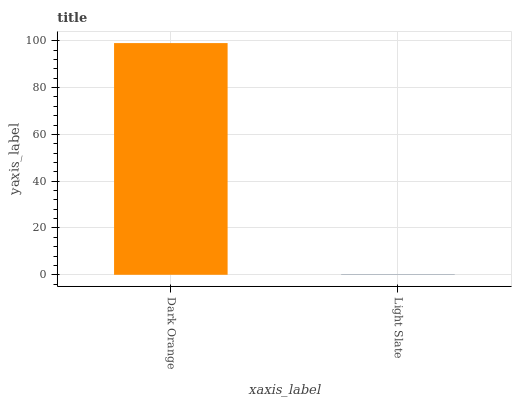Is Light Slate the minimum?
Answer yes or no. Yes. Is Dark Orange the maximum?
Answer yes or no. Yes. Is Light Slate the maximum?
Answer yes or no. No. Is Dark Orange greater than Light Slate?
Answer yes or no. Yes. Is Light Slate less than Dark Orange?
Answer yes or no. Yes. Is Light Slate greater than Dark Orange?
Answer yes or no. No. Is Dark Orange less than Light Slate?
Answer yes or no. No. Is Dark Orange the high median?
Answer yes or no. Yes. Is Light Slate the low median?
Answer yes or no. Yes. Is Light Slate the high median?
Answer yes or no. No. Is Dark Orange the low median?
Answer yes or no. No. 